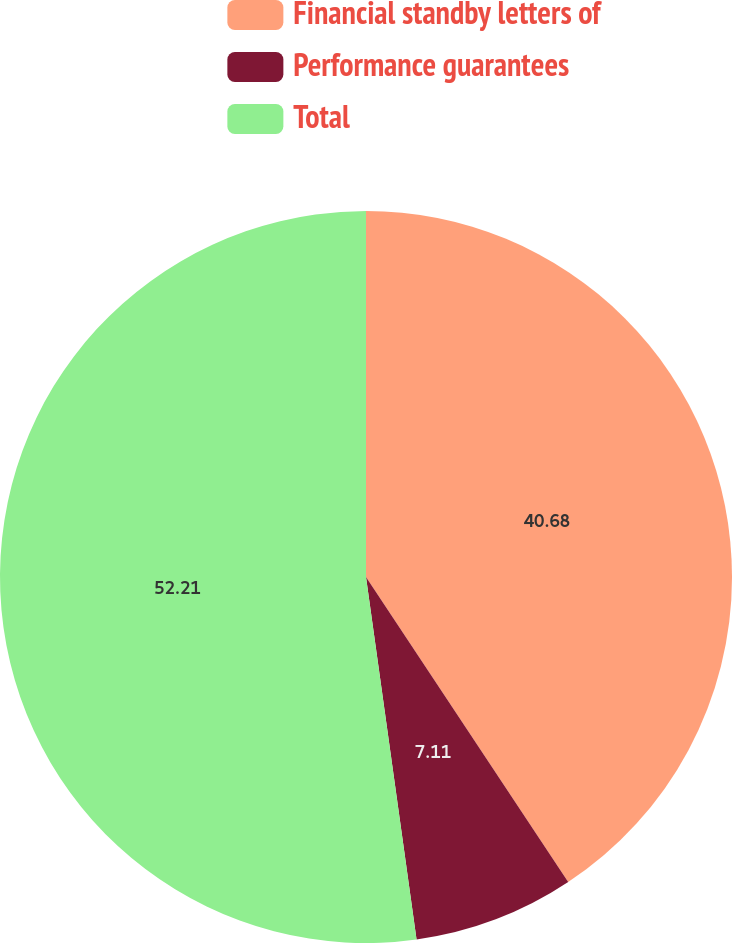<chart> <loc_0><loc_0><loc_500><loc_500><pie_chart><fcel>Financial standby letters of<fcel>Performance guarantees<fcel>Total<nl><fcel>40.68%<fcel>7.11%<fcel>52.2%<nl></chart> 